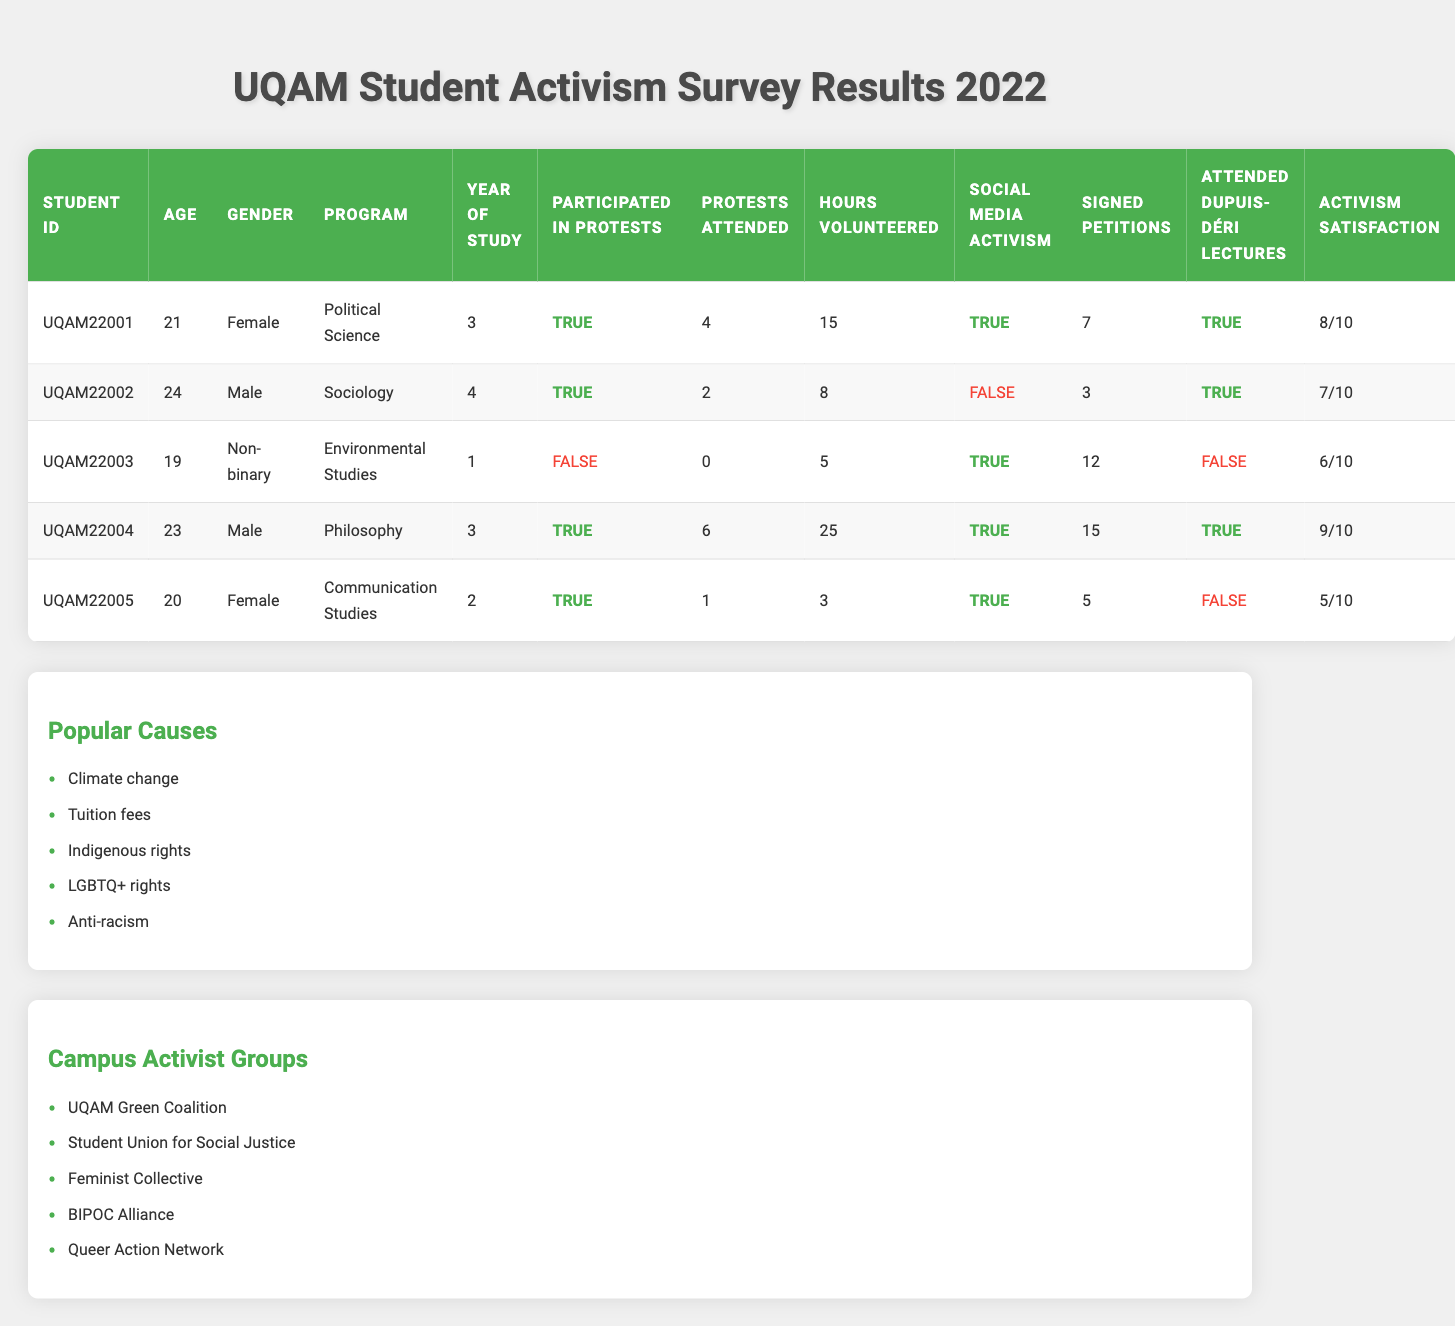What is the age of the student with ID UQAM22003? The table lists UQAM22003 under the student ID column. Referring to the same row, the age of this student is indicated as 19.
Answer: 19 How many total hours did student UQAM22004 volunteer? Referring to the row for student UQAM22004, the number of hours volunteered is shown as 25.
Answer: 25 Did any student not attend Dupuis-Déri lectures? By looking at the 'Attended Dupuis-Déri Lectures' column, UQAM22003 and UQAM22005 are marked as false, indicating they did not attend the lectures.
Answer: Yes What is the activism satisfaction score of the student who participated in 6 protests? The student with 6 protests attended is UQAM22004. In the same row, the activism satisfaction score is 9.
Answer: 9 How many students volunteered more than 10 hours? The students UQAM22001 (15 hours), UQAM22004 (25 hours) volunteered more than 10 hours. Counting these, we find 2 students.
Answer: 2 What is the average number of protests attended by students who participated in protests? The number of protests attended by those who participated are: 4 (UQAM22001), 2 (UQAM22002), 6 (UQAM22004), and 1 (UQAM22005). Summing these gives 4 + 2 + 6 + 1 = 13. There are 4 students, so the average is 13/4 = 3.25.
Answer: 3.25 Is there a correlation between the number of times students signed petitions and their activism satisfaction? Reviewing the data, the following scores can be analyzed: UQAM22001 (7 petitions, satisfaction 8), UQAM22002 (3 petitions, satisfaction 7), UQAM22003 (12 petitions, satisfaction 6), UQAM22004 (15 petitions, satisfaction 9), and UQAM22005 (5 petitions, satisfaction 5). No straightforward correlation is observed as the satisfaction does not strictly increase with the number of petitions signed.
Answer: No strong correlation Which program had the highest average activism satisfaction score? The scores by program are as follows: Political Science (8), Sociology (7), Environmental Studies (6), Philosophy (9), and Communication Studies (5). Calculating the average: Political Science (8) and Philosophy (9) have the highest scores.
Answer: Philosophy How many students are involved in social media activism, and what is their average activism satisfaction? Students UQAM22001, UQAM22003, UQAM22004, and UQAM22005 are involved in social media activism (4 students). Their activism satisfaction scores are 8, 6, 9, and 5 respectively, summing to 28 and averaging 28/4 = 7.
Answer: 7 What is the final count of students who didn't participate in protests? Only UQAM22003 is marked as not participating in protests, as seen in the table. Therefore, the count is 1.
Answer: 1 